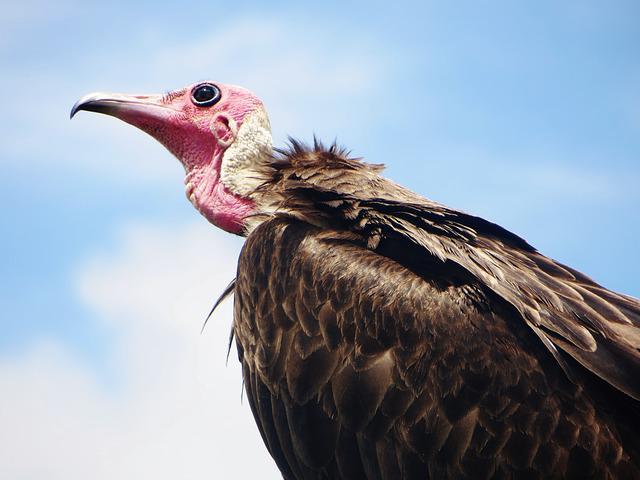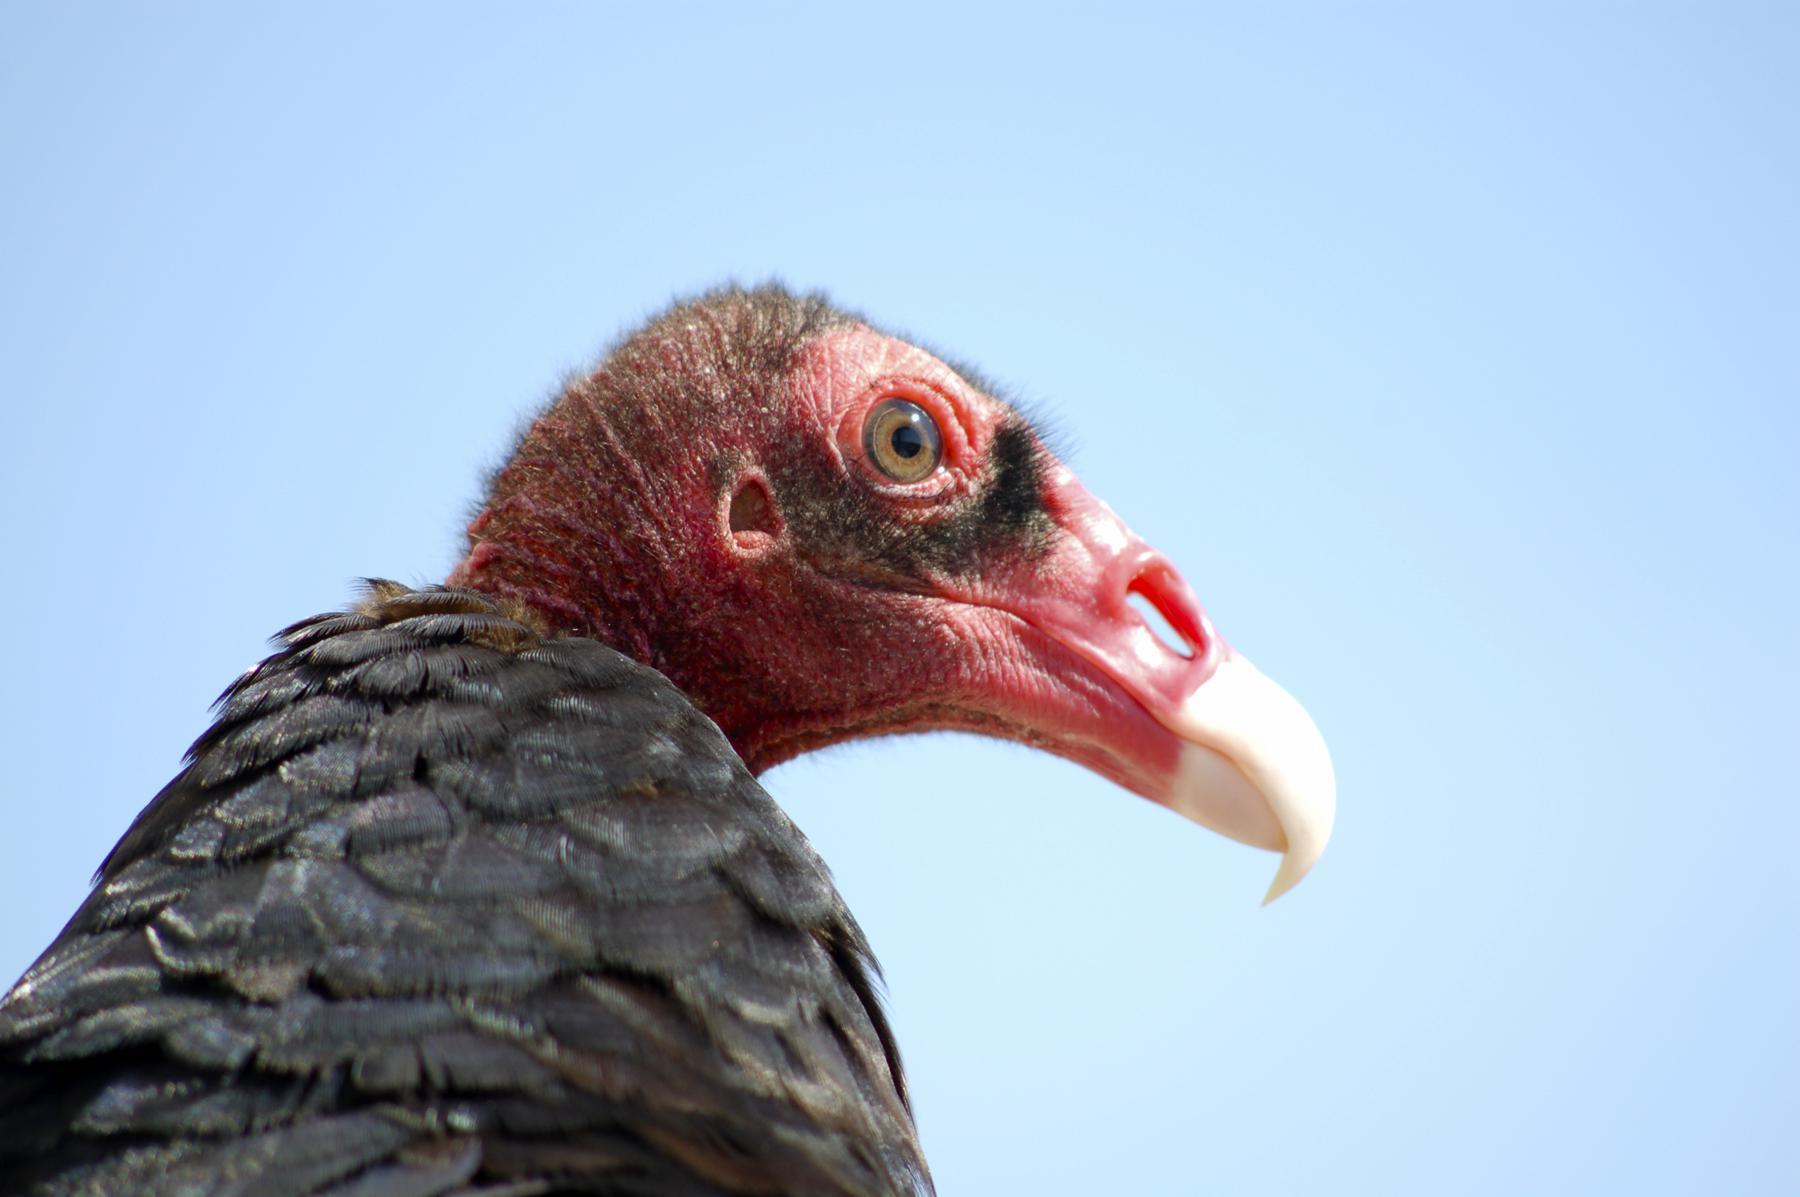The first image is the image on the left, the second image is the image on the right. Assess this claim about the two images: "All of the birds are flying.". Correct or not? Answer yes or no. No. The first image is the image on the left, the second image is the image on the right. For the images displayed, is the sentence "The bird on the right image is facing right." factually correct? Answer yes or no. Yes. 